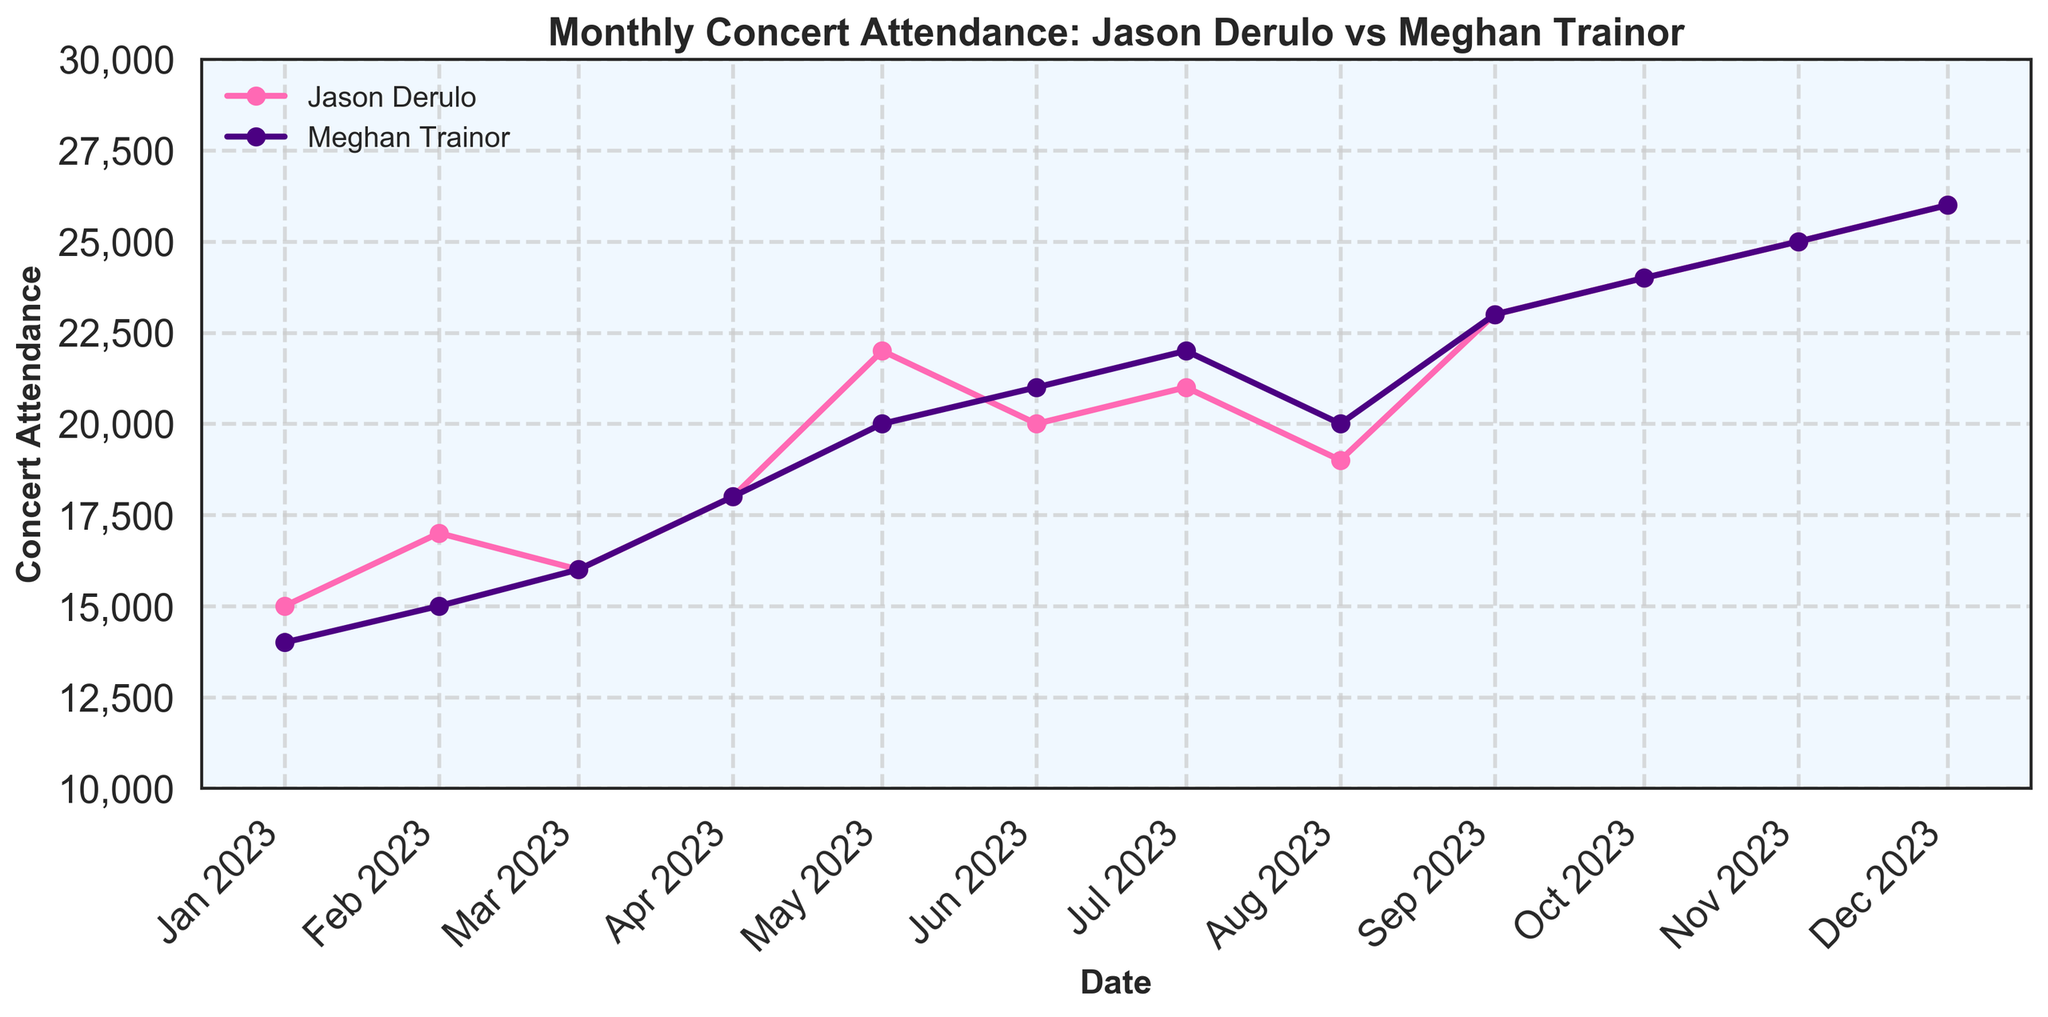What's the title of the plot? The title of the plot is prominently displayed at the top, which is "Monthly Concert Attendance: Jason Derulo vs Meghan Trainor".
Answer: Monthly Concert Attendance: Jason Derulo vs Meghan Trainor What is the range of months shown in the plot? The x-axis shows the time range from January 2023 to December 2023, denoting a full year's worth of data.
Answer: January 2023 to December 2023 What color represents Jason Derulo's data line? Jason Derulo's data line is shown in pink, as indicated by the color of the line and the corresponding legend label.
Answer: Pink What was the highest attendance for Meghan Trainor in 2023? By looking at Meghan Trainor's purple data points, her highest attendance occurred in December 2023 and hit 26,000 attendees.
Answer: 26,000 In which month did Jason Derulo and Meghan Trainor both first reach 20,000 attendees? By tracking both lines visually, May 2023 is the month when both Jason Derulo and Meghan Trainor first reached 20,000 attendees.
Answer: May 2023 How many months showed an increase in attendance for Jason Derulo? From the data points on the plot, Jason Derulo's attendance increased in 8 months: February, April, May, July, September, October, November, and December.
Answer: 8 months Which artist had a steeper rise in attendance from January to April 2023? Both artists show an increase, but Meghan Trainor’s rise from 14,000 in January to 18,000 in April (a 4,000 rise) is steeper compared to Jason Derulo’s rise from 15,000 to 18,000 (a 3,000 rise).
Answer: Meghan Trainor During which months did both Jason Derulo and Meghan Trainor's attendances exceed 22,000? By carefully looking at the timeline and the y-axis values, both artists exceeded 22,000 attendees in September, October, November, and December.
Answer: September, October, November, December Which artist had higher concert attendance in August 2023 and by how much? In August 2023, Jason Derulo had 19,000 attendees while Meghan Trainor had 20,000 attendees. Therefore, Meghan Trainor had 1,000 more attendees than Jason Derulo.
Answer: Meghan Trainor by 1,000 What is the average monthly attendance for Jason Derulo from July to December 2023? Summing the monthly attendances from July (21,000), August (19,000), September (23,000), October (24,000), November (25,000), and December (26,000) gives 138,000. Dividing this by 6 months results in an average of 23,000 attendees.
Answer: 23,000 